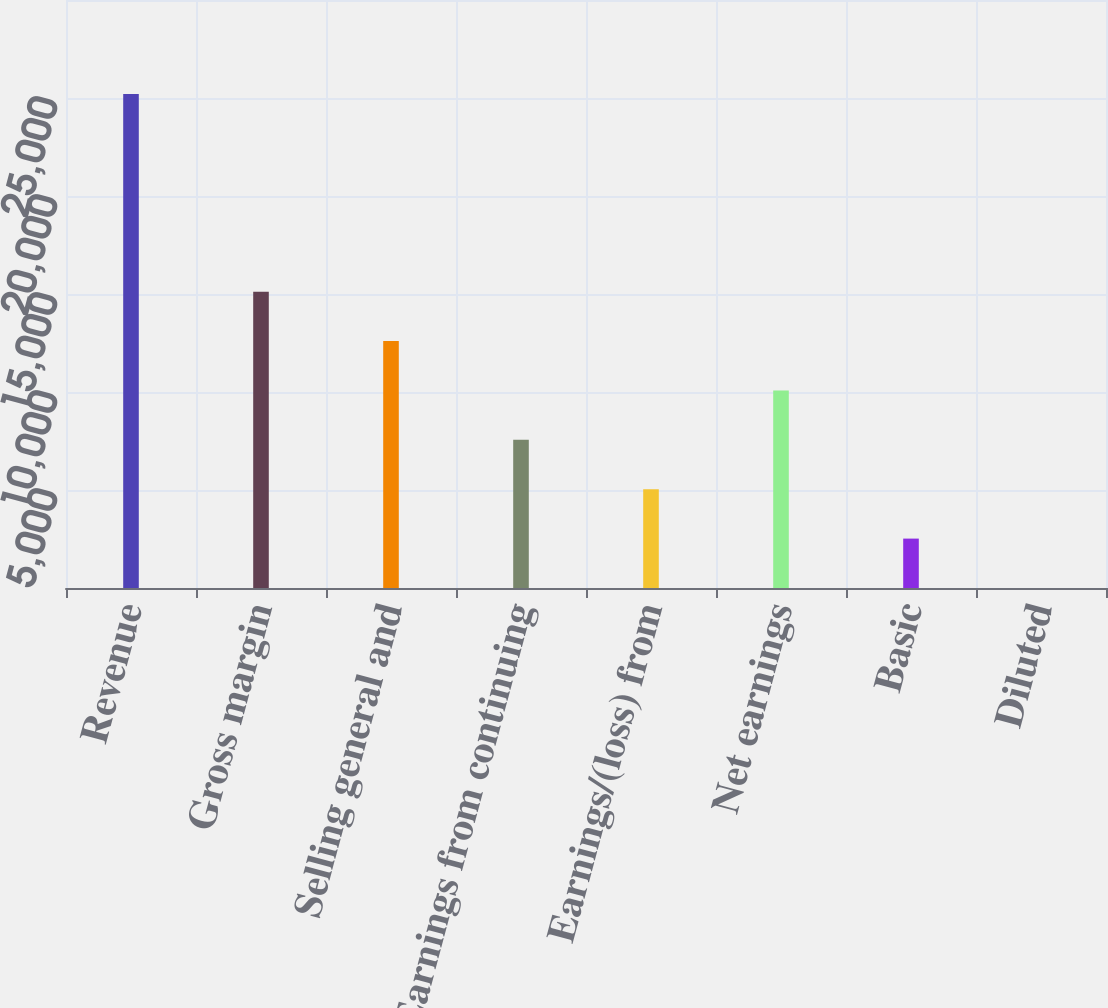Convert chart to OTSL. <chart><loc_0><loc_0><loc_500><loc_500><bar_chart><fcel>Revenue<fcel>Gross margin<fcel>Selling general and<fcel>Earnings from continuing<fcel>Earnings/(loss) from<fcel>Net earnings<fcel>Basic<fcel>Diluted<nl><fcel>25198.9<fcel>15119.7<fcel>12599.8<fcel>7560.2<fcel>5040.38<fcel>10080<fcel>2520.56<fcel>0.74<nl></chart> 